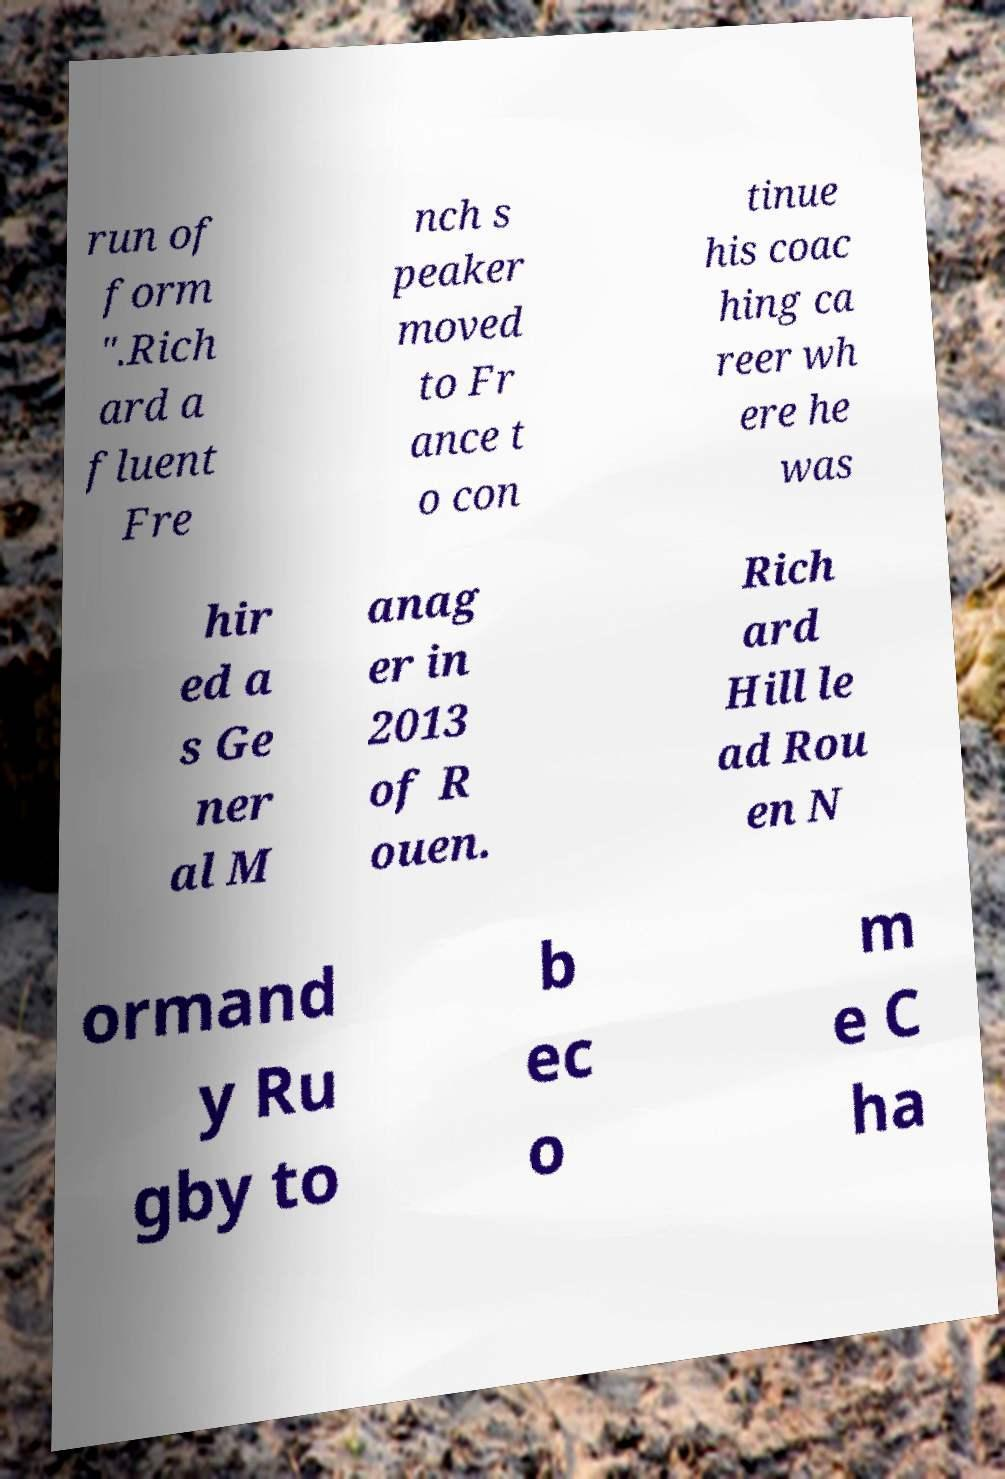Could you assist in decoding the text presented in this image and type it out clearly? run of form ".Rich ard a fluent Fre nch s peaker moved to Fr ance t o con tinue his coac hing ca reer wh ere he was hir ed a s Ge ner al M anag er in 2013 of R ouen. Rich ard Hill le ad Rou en N ormand y Ru gby to b ec o m e C ha 